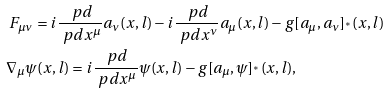<formula> <loc_0><loc_0><loc_500><loc_500>& \ F _ { \mu \nu } = i \frac { \ p d } { \ p d x ^ { \mu } } a _ { \nu } ( x , l ) - i \frac { \ p d } { \ p d x ^ { \nu } } a _ { \mu } ( x , l ) - g [ a _ { \mu } , a _ { \nu } ] _ { ^ { * } } ( x , l ) \\ & \nabla _ { \mu } \psi ( x , l ) = i \frac { \ p d } { \ p d x ^ { \mu } } \psi ( x , l ) - g [ a _ { \mu } , \psi ] _ { ^ { * } } ( x , l ) ,</formula> 